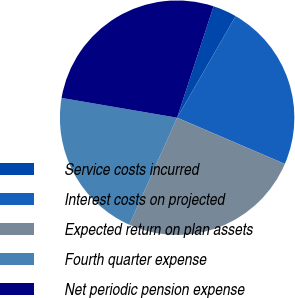<chart> <loc_0><loc_0><loc_500><loc_500><pie_chart><fcel>Service costs incurred<fcel>Interest costs on projected<fcel>Expected return on plan assets<fcel>Fourth quarter expense<fcel>Net periodic pension expense<nl><fcel>3.29%<fcel>23.13%<fcel>25.23%<fcel>21.02%<fcel>27.33%<nl></chart> 